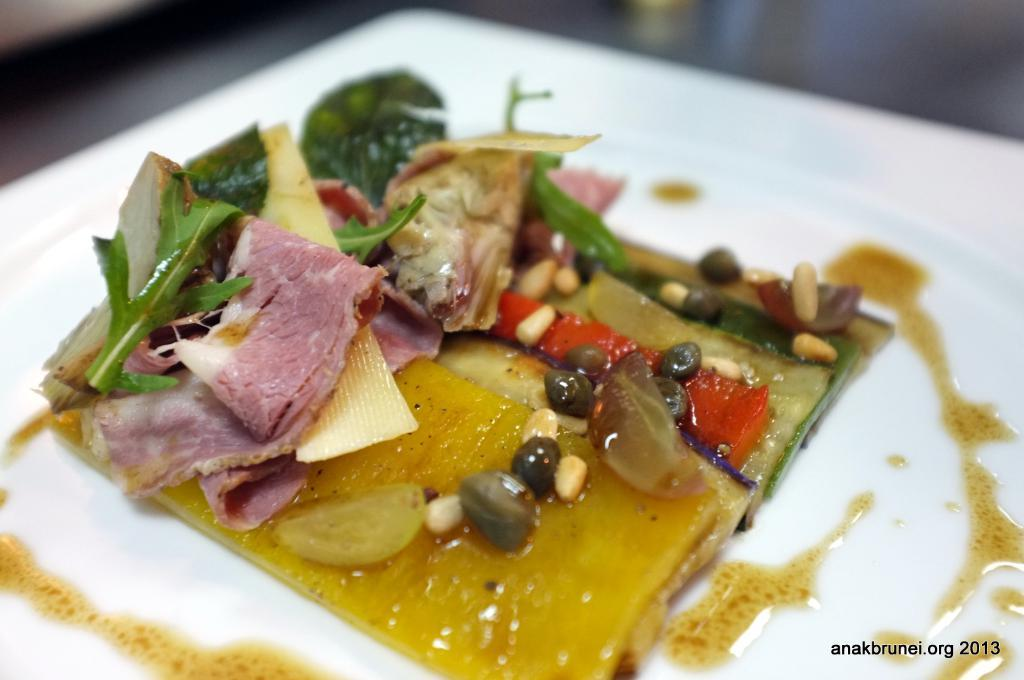What type of food can be seen in the image? There is cooked food in the image. How is the cooked food presented? The cooked food is served on a white plate. What type of property is visible in the image? There is no property visible in the image; it only features cooked food served on a white plate. 